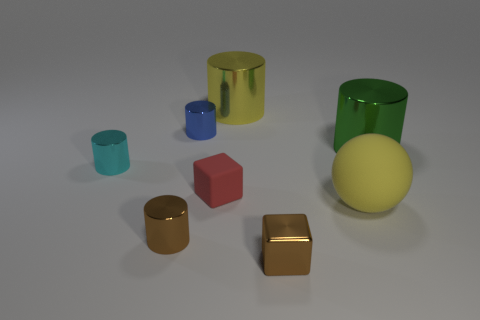Subtract all cylinders. How many objects are left? 3 Subtract 2 cubes. How many cubes are left? 0 Subtract all gray blocks. Subtract all brown cylinders. How many blocks are left? 2 Subtract all brown blocks. How many yellow cylinders are left? 1 Subtract all big yellow rubber things. Subtract all matte spheres. How many objects are left? 6 Add 7 tiny cyan metal cylinders. How many tiny cyan metal cylinders are left? 8 Add 1 red rubber blocks. How many red rubber blocks exist? 2 Add 2 large purple metallic things. How many objects exist? 10 Subtract all red cubes. How many cubes are left? 1 Subtract all small brown shiny cylinders. How many cylinders are left? 4 